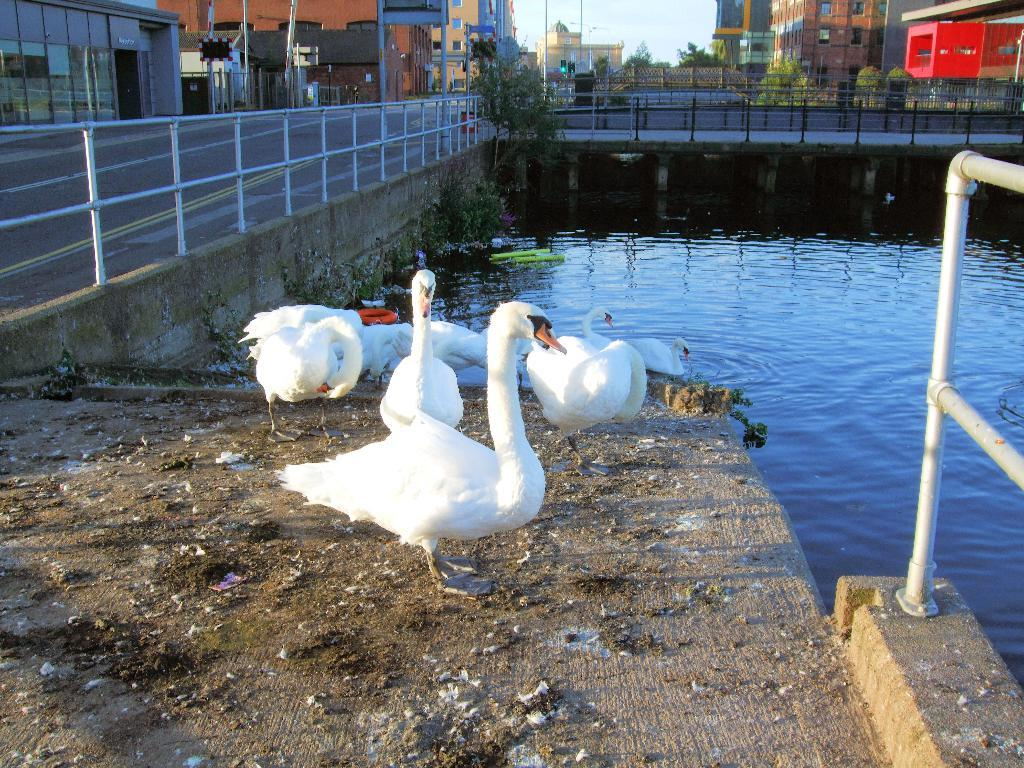What type of animals can be seen in the image? There are birds in the image. What color are the birds? The birds are white in color. What can be seen in the background of the image? Buildings, trees, poles, signboards, railing, water, and the sky are visible in the background of the image. What is the color of the sky in the image? The sky is white and blue in color. What type of wool is being used to transport the birds in the image? There is no wool or transportation of birds present in the image. 